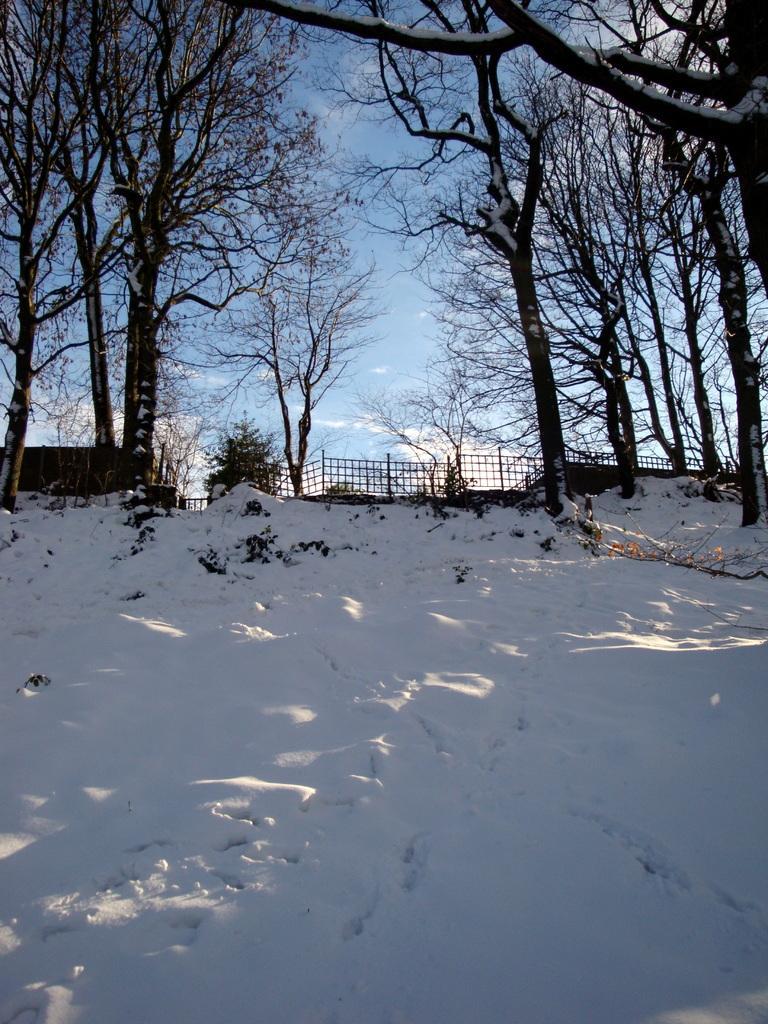In one or two sentences, can you explain what this image depicts? In the image in the center we can see the sky,clouds,trees,fences and snow. 